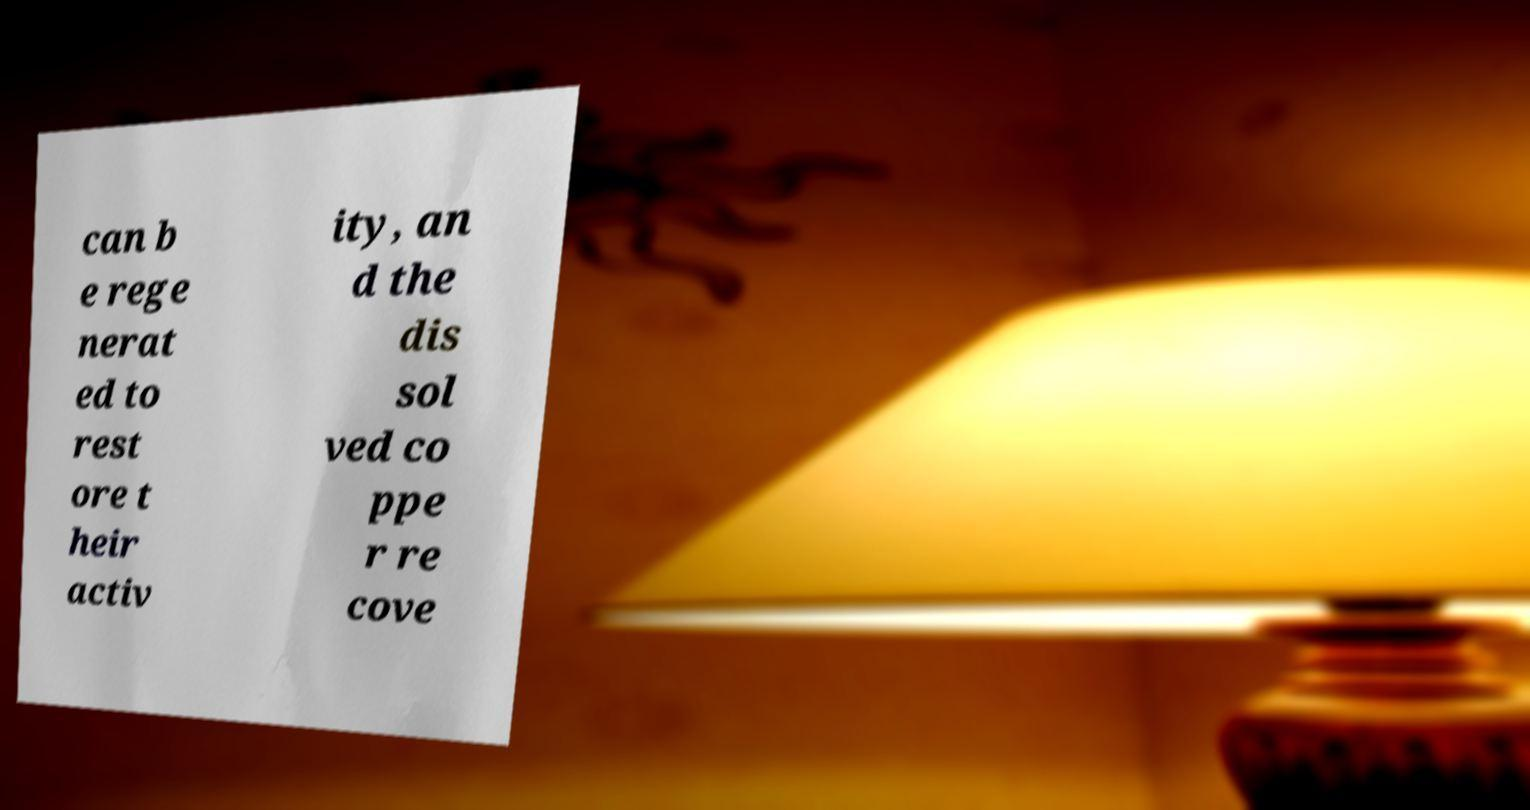Please read and relay the text visible in this image. What does it say? can b e rege nerat ed to rest ore t heir activ ity, an d the dis sol ved co ppe r re cove 